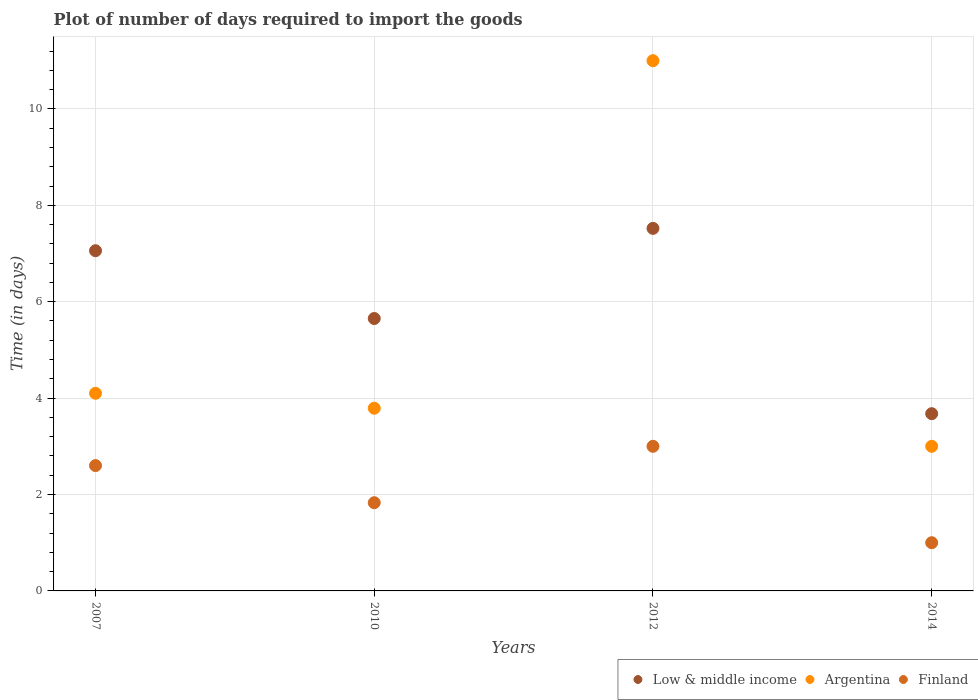Is the number of dotlines equal to the number of legend labels?
Provide a short and direct response. Yes. What is the time required to import goods in Finland in 2007?
Ensure brevity in your answer.  2.6. Across all years, what is the maximum time required to import goods in Low & middle income?
Give a very brief answer. 7.52. Across all years, what is the minimum time required to import goods in Low & middle income?
Keep it short and to the point. 3.68. In which year was the time required to import goods in Argentina minimum?
Offer a very short reply. 2014. What is the total time required to import goods in Low & middle income in the graph?
Offer a terse response. 23.91. What is the difference between the time required to import goods in Low & middle income in 2007 and that in 2010?
Offer a very short reply. 1.41. What is the difference between the time required to import goods in Finland in 2012 and the time required to import goods in Argentina in 2010?
Your answer should be very brief. -0.79. What is the average time required to import goods in Finland per year?
Give a very brief answer. 2.11. In the year 2012, what is the difference between the time required to import goods in Argentina and time required to import goods in Low & middle income?
Your answer should be very brief. 3.48. What is the ratio of the time required to import goods in Argentina in 2010 to that in 2012?
Offer a terse response. 0.34. Is the difference between the time required to import goods in Argentina in 2010 and 2012 greater than the difference between the time required to import goods in Low & middle income in 2010 and 2012?
Your answer should be compact. No. What is the difference between the highest and the second highest time required to import goods in Finland?
Offer a very short reply. 0.4. What is the difference between the highest and the lowest time required to import goods in Finland?
Keep it short and to the point. 2. Is the sum of the time required to import goods in Finland in 2010 and 2012 greater than the maximum time required to import goods in Argentina across all years?
Ensure brevity in your answer.  No. Is it the case that in every year, the sum of the time required to import goods in Finland and time required to import goods in Argentina  is greater than the time required to import goods in Low & middle income?
Your response must be concise. No. Is the time required to import goods in Finland strictly greater than the time required to import goods in Argentina over the years?
Offer a terse response. No. Is the time required to import goods in Finland strictly less than the time required to import goods in Argentina over the years?
Provide a short and direct response. Yes. Are the values on the major ticks of Y-axis written in scientific E-notation?
Your answer should be very brief. No. Does the graph contain any zero values?
Ensure brevity in your answer.  No. How are the legend labels stacked?
Offer a terse response. Horizontal. What is the title of the graph?
Ensure brevity in your answer.  Plot of number of days required to import the goods. What is the label or title of the Y-axis?
Keep it short and to the point. Time (in days). What is the Time (in days) in Low & middle income in 2007?
Your response must be concise. 7.06. What is the Time (in days) in Argentina in 2007?
Offer a terse response. 4.1. What is the Time (in days) of Low & middle income in 2010?
Make the answer very short. 5.65. What is the Time (in days) in Argentina in 2010?
Keep it short and to the point. 3.79. What is the Time (in days) in Finland in 2010?
Your response must be concise. 1.83. What is the Time (in days) in Low & middle income in 2012?
Make the answer very short. 7.52. What is the Time (in days) in Argentina in 2012?
Make the answer very short. 11. What is the Time (in days) in Finland in 2012?
Offer a terse response. 3. What is the Time (in days) of Low & middle income in 2014?
Keep it short and to the point. 3.68. What is the Time (in days) of Argentina in 2014?
Provide a succinct answer. 3. What is the Time (in days) of Finland in 2014?
Give a very brief answer. 1. Across all years, what is the maximum Time (in days) in Low & middle income?
Ensure brevity in your answer.  7.52. Across all years, what is the maximum Time (in days) in Finland?
Provide a succinct answer. 3. Across all years, what is the minimum Time (in days) in Low & middle income?
Offer a very short reply. 3.68. What is the total Time (in days) of Low & middle income in the graph?
Your response must be concise. 23.91. What is the total Time (in days) in Argentina in the graph?
Your answer should be very brief. 21.89. What is the total Time (in days) of Finland in the graph?
Make the answer very short. 8.43. What is the difference between the Time (in days) of Low & middle income in 2007 and that in 2010?
Ensure brevity in your answer.  1.41. What is the difference between the Time (in days) in Argentina in 2007 and that in 2010?
Provide a succinct answer. 0.31. What is the difference between the Time (in days) of Finland in 2007 and that in 2010?
Provide a succinct answer. 0.77. What is the difference between the Time (in days) in Low & middle income in 2007 and that in 2012?
Give a very brief answer. -0.46. What is the difference between the Time (in days) in Argentina in 2007 and that in 2012?
Ensure brevity in your answer.  -6.9. What is the difference between the Time (in days) in Low & middle income in 2007 and that in 2014?
Provide a succinct answer. 3.38. What is the difference between the Time (in days) of Finland in 2007 and that in 2014?
Keep it short and to the point. 1.6. What is the difference between the Time (in days) of Low & middle income in 2010 and that in 2012?
Offer a terse response. -1.87. What is the difference between the Time (in days) in Argentina in 2010 and that in 2012?
Your response must be concise. -7.21. What is the difference between the Time (in days) of Finland in 2010 and that in 2012?
Ensure brevity in your answer.  -1.17. What is the difference between the Time (in days) in Low & middle income in 2010 and that in 2014?
Ensure brevity in your answer.  1.97. What is the difference between the Time (in days) of Argentina in 2010 and that in 2014?
Provide a succinct answer. 0.79. What is the difference between the Time (in days) of Finland in 2010 and that in 2014?
Keep it short and to the point. 0.83. What is the difference between the Time (in days) of Low & middle income in 2012 and that in 2014?
Provide a succinct answer. 3.84. What is the difference between the Time (in days) in Argentina in 2012 and that in 2014?
Provide a short and direct response. 8. What is the difference between the Time (in days) in Low & middle income in 2007 and the Time (in days) in Argentina in 2010?
Provide a succinct answer. 3.27. What is the difference between the Time (in days) of Low & middle income in 2007 and the Time (in days) of Finland in 2010?
Make the answer very short. 5.23. What is the difference between the Time (in days) in Argentina in 2007 and the Time (in days) in Finland in 2010?
Provide a short and direct response. 2.27. What is the difference between the Time (in days) of Low & middle income in 2007 and the Time (in days) of Argentina in 2012?
Offer a very short reply. -3.94. What is the difference between the Time (in days) of Low & middle income in 2007 and the Time (in days) of Finland in 2012?
Give a very brief answer. 4.06. What is the difference between the Time (in days) in Low & middle income in 2007 and the Time (in days) in Argentina in 2014?
Your answer should be very brief. 4.06. What is the difference between the Time (in days) in Low & middle income in 2007 and the Time (in days) in Finland in 2014?
Keep it short and to the point. 6.06. What is the difference between the Time (in days) in Low & middle income in 2010 and the Time (in days) in Argentina in 2012?
Provide a short and direct response. -5.35. What is the difference between the Time (in days) of Low & middle income in 2010 and the Time (in days) of Finland in 2012?
Give a very brief answer. 2.65. What is the difference between the Time (in days) in Argentina in 2010 and the Time (in days) in Finland in 2012?
Give a very brief answer. 0.79. What is the difference between the Time (in days) in Low & middle income in 2010 and the Time (in days) in Argentina in 2014?
Offer a terse response. 2.65. What is the difference between the Time (in days) of Low & middle income in 2010 and the Time (in days) of Finland in 2014?
Provide a short and direct response. 4.65. What is the difference between the Time (in days) in Argentina in 2010 and the Time (in days) in Finland in 2014?
Ensure brevity in your answer.  2.79. What is the difference between the Time (in days) in Low & middle income in 2012 and the Time (in days) in Argentina in 2014?
Give a very brief answer. 4.52. What is the difference between the Time (in days) in Low & middle income in 2012 and the Time (in days) in Finland in 2014?
Offer a very short reply. 6.52. What is the average Time (in days) in Low & middle income per year?
Offer a very short reply. 5.98. What is the average Time (in days) in Argentina per year?
Keep it short and to the point. 5.47. What is the average Time (in days) of Finland per year?
Provide a succinct answer. 2.11. In the year 2007, what is the difference between the Time (in days) of Low & middle income and Time (in days) of Argentina?
Provide a short and direct response. 2.96. In the year 2007, what is the difference between the Time (in days) of Low & middle income and Time (in days) of Finland?
Provide a succinct answer. 4.46. In the year 2010, what is the difference between the Time (in days) of Low & middle income and Time (in days) of Argentina?
Your answer should be compact. 1.86. In the year 2010, what is the difference between the Time (in days) in Low & middle income and Time (in days) in Finland?
Keep it short and to the point. 3.82. In the year 2010, what is the difference between the Time (in days) of Argentina and Time (in days) of Finland?
Your response must be concise. 1.96. In the year 2012, what is the difference between the Time (in days) of Low & middle income and Time (in days) of Argentina?
Offer a terse response. -3.48. In the year 2012, what is the difference between the Time (in days) of Low & middle income and Time (in days) of Finland?
Offer a terse response. 4.52. In the year 2014, what is the difference between the Time (in days) of Low & middle income and Time (in days) of Argentina?
Your answer should be compact. 0.68. In the year 2014, what is the difference between the Time (in days) in Low & middle income and Time (in days) in Finland?
Your answer should be very brief. 2.68. In the year 2014, what is the difference between the Time (in days) of Argentina and Time (in days) of Finland?
Provide a succinct answer. 2. What is the ratio of the Time (in days) of Low & middle income in 2007 to that in 2010?
Offer a terse response. 1.25. What is the ratio of the Time (in days) of Argentina in 2007 to that in 2010?
Give a very brief answer. 1.08. What is the ratio of the Time (in days) of Finland in 2007 to that in 2010?
Ensure brevity in your answer.  1.42. What is the ratio of the Time (in days) in Low & middle income in 2007 to that in 2012?
Keep it short and to the point. 0.94. What is the ratio of the Time (in days) of Argentina in 2007 to that in 2012?
Provide a succinct answer. 0.37. What is the ratio of the Time (in days) in Finland in 2007 to that in 2012?
Make the answer very short. 0.87. What is the ratio of the Time (in days) in Low & middle income in 2007 to that in 2014?
Keep it short and to the point. 1.92. What is the ratio of the Time (in days) in Argentina in 2007 to that in 2014?
Offer a very short reply. 1.37. What is the ratio of the Time (in days) in Low & middle income in 2010 to that in 2012?
Your response must be concise. 0.75. What is the ratio of the Time (in days) in Argentina in 2010 to that in 2012?
Your answer should be compact. 0.34. What is the ratio of the Time (in days) in Finland in 2010 to that in 2012?
Keep it short and to the point. 0.61. What is the ratio of the Time (in days) of Low & middle income in 2010 to that in 2014?
Provide a succinct answer. 1.54. What is the ratio of the Time (in days) in Argentina in 2010 to that in 2014?
Your answer should be compact. 1.26. What is the ratio of the Time (in days) of Finland in 2010 to that in 2014?
Offer a terse response. 1.83. What is the ratio of the Time (in days) of Low & middle income in 2012 to that in 2014?
Provide a short and direct response. 2.05. What is the ratio of the Time (in days) in Argentina in 2012 to that in 2014?
Your answer should be compact. 3.67. What is the ratio of the Time (in days) of Finland in 2012 to that in 2014?
Your response must be concise. 3. What is the difference between the highest and the second highest Time (in days) of Low & middle income?
Keep it short and to the point. 0.46. What is the difference between the highest and the second highest Time (in days) in Argentina?
Your answer should be compact. 6.9. What is the difference between the highest and the second highest Time (in days) in Finland?
Keep it short and to the point. 0.4. What is the difference between the highest and the lowest Time (in days) of Low & middle income?
Provide a succinct answer. 3.84. What is the difference between the highest and the lowest Time (in days) of Argentina?
Offer a very short reply. 8. What is the difference between the highest and the lowest Time (in days) in Finland?
Give a very brief answer. 2. 